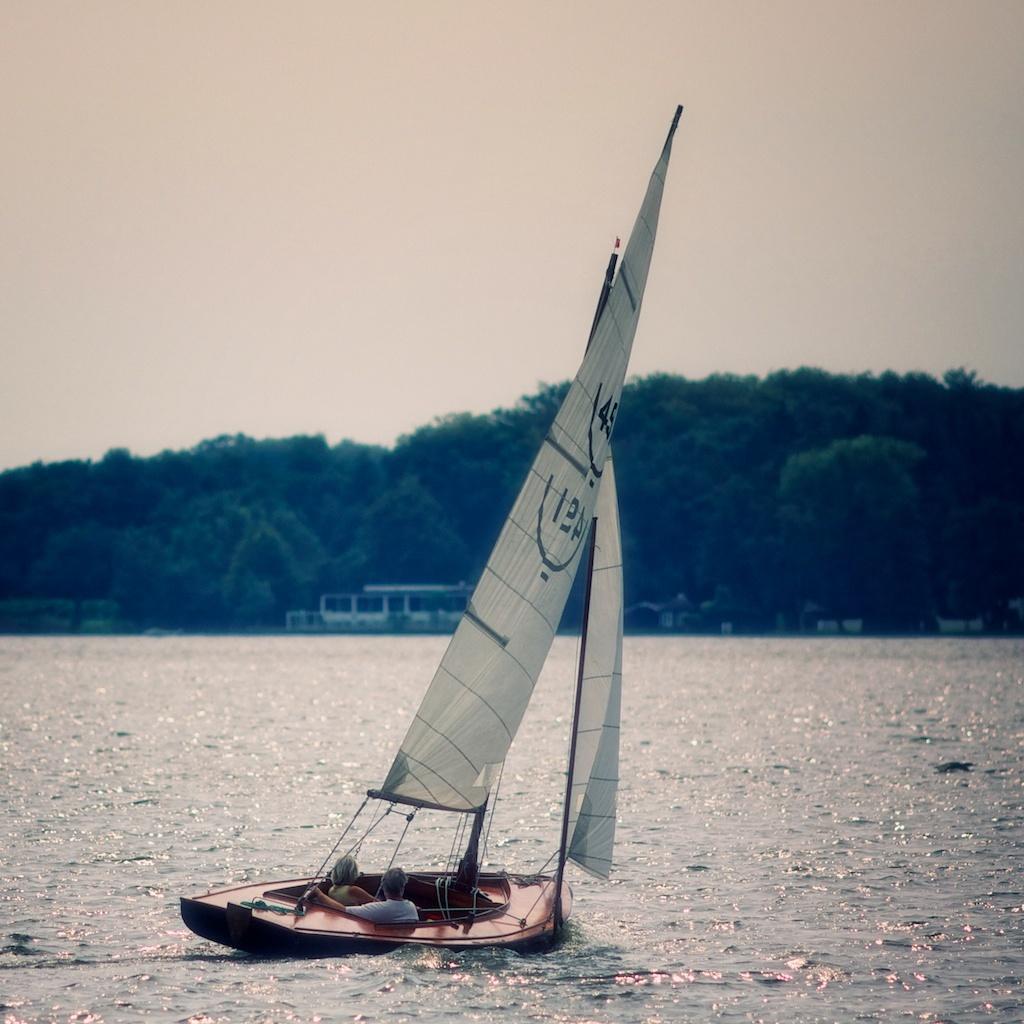Can you describe this image briefly? In this image we can see two persons sitting in a sailboat placed in water. In the background, we can see a building, group of trees and sky. 